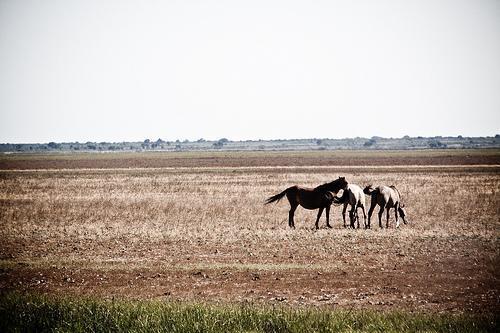How many people are pictured here?
Give a very brief answer. 0. How many horses are shown?
Give a very brief answer. 3. 